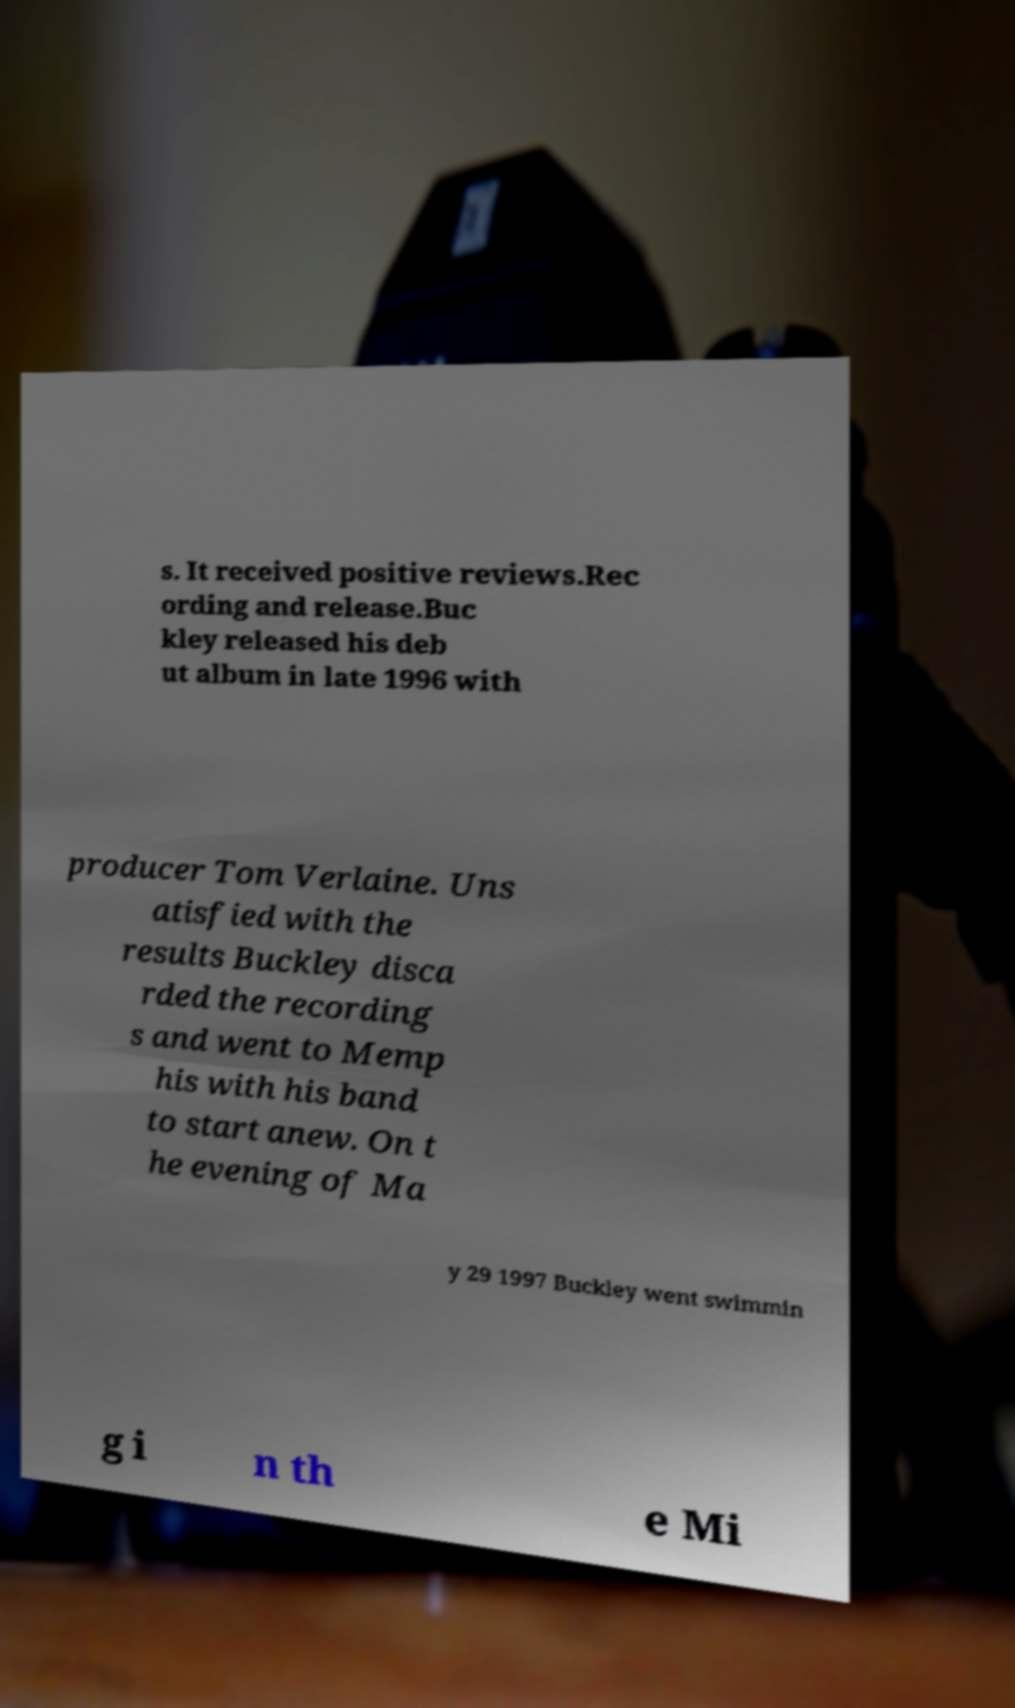For documentation purposes, I need the text within this image transcribed. Could you provide that? s. It received positive reviews.Rec ording and release.Buc kley released his deb ut album in late 1996 with producer Tom Verlaine. Uns atisfied with the results Buckley disca rded the recording s and went to Memp his with his band to start anew. On t he evening of Ma y 29 1997 Buckley went swimmin g i n th e Mi 